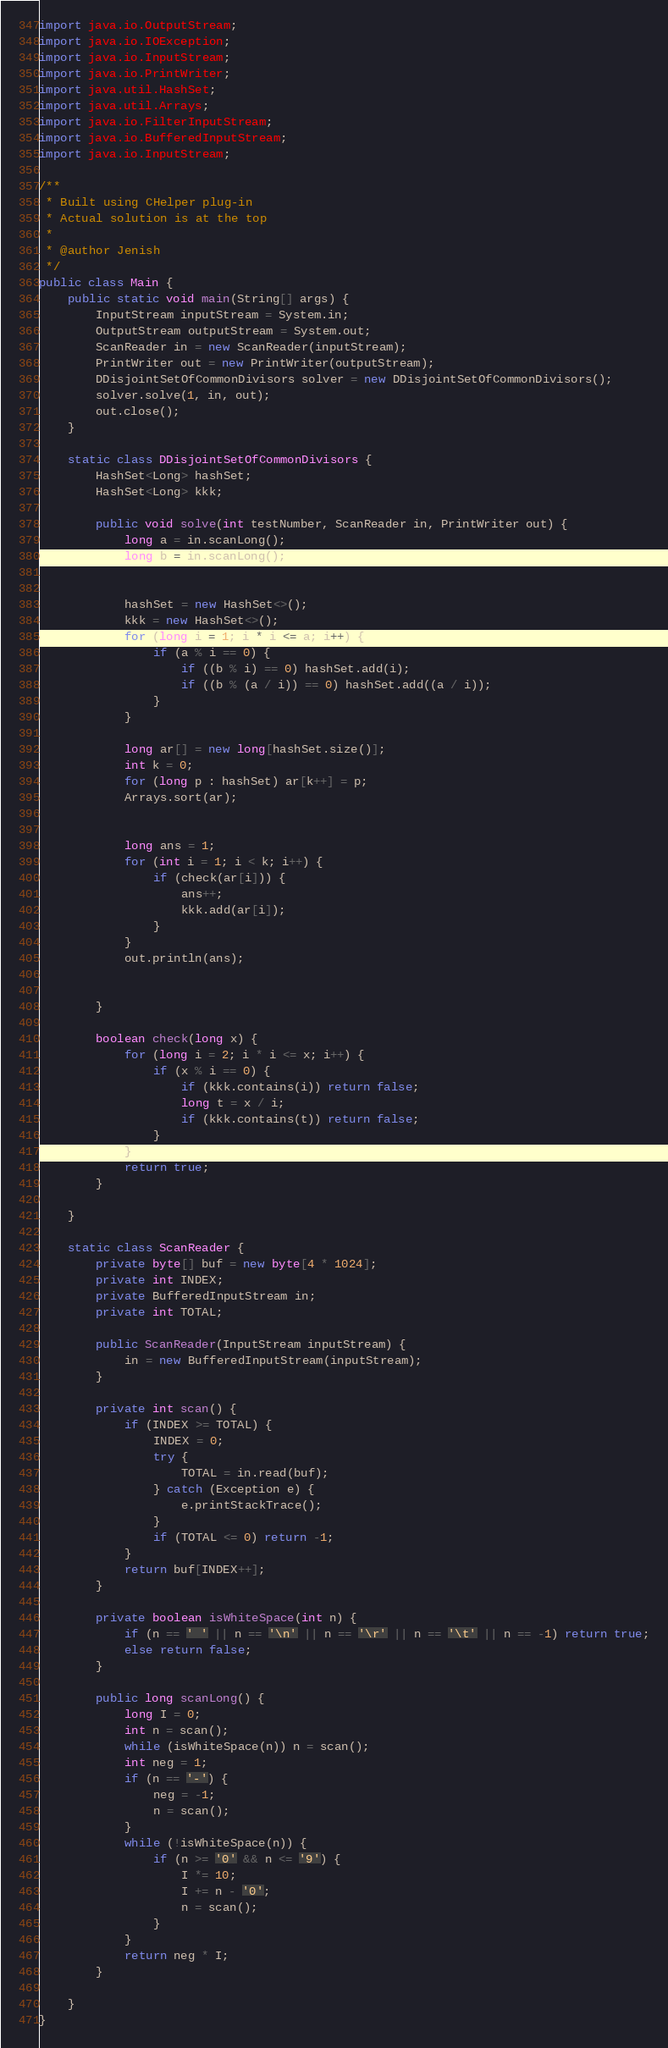<code> <loc_0><loc_0><loc_500><loc_500><_Java_>import java.io.OutputStream;
import java.io.IOException;
import java.io.InputStream;
import java.io.PrintWriter;
import java.util.HashSet;
import java.util.Arrays;
import java.io.FilterInputStream;
import java.io.BufferedInputStream;
import java.io.InputStream;

/**
 * Built using CHelper plug-in
 * Actual solution is at the top
 *
 * @author Jenish
 */
public class Main {
    public static void main(String[] args) {
        InputStream inputStream = System.in;
        OutputStream outputStream = System.out;
        ScanReader in = new ScanReader(inputStream);
        PrintWriter out = new PrintWriter(outputStream);
        DDisjointSetOfCommonDivisors solver = new DDisjointSetOfCommonDivisors();
        solver.solve(1, in, out);
        out.close();
    }

    static class DDisjointSetOfCommonDivisors {
        HashSet<Long> hashSet;
        HashSet<Long> kkk;

        public void solve(int testNumber, ScanReader in, PrintWriter out) {
            long a = in.scanLong();
            long b = in.scanLong();


            hashSet = new HashSet<>();
            kkk = new HashSet<>();
            for (long i = 1; i * i <= a; i++) {
                if (a % i == 0) {
                    if ((b % i) == 0) hashSet.add(i);
                    if ((b % (a / i)) == 0) hashSet.add((a / i));
                }
            }

            long ar[] = new long[hashSet.size()];
            int k = 0;
            for (long p : hashSet) ar[k++] = p;
            Arrays.sort(ar);


            long ans = 1;
            for (int i = 1; i < k; i++) {
                if (check(ar[i])) {
                    ans++;
                    kkk.add(ar[i]);
                }
            }
            out.println(ans);


        }

        boolean check(long x) {
            for (long i = 2; i * i <= x; i++) {
                if (x % i == 0) {
                    if (kkk.contains(i)) return false;
                    long t = x / i;
                    if (kkk.contains(t)) return false;
                }
            }
            return true;
        }

    }

    static class ScanReader {
        private byte[] buf = new byte[4 * 1024];
        private int INDEX;
        private BufferedInputStream in;
        private int TOTAL;

        public ScanReader(InputStream inputStream) {
            in = new BufferedInputStream(inputStream);
        }

        private int scan() {
            if (INDEX >= TOTAL) {
                INDEX = 0;
                try {
                    TOTAL = in.read(buf);
                } catch (Exception e) {
                    e.printStackTrace();
                }
                if (TOTAL <= 0) return -1;
            }
            return buf[INDEX++];
        }

        private boolean isWhiteSpace(int n) {
            if (n == ' ' || n == '\n' || n == '\r' || n == '\t' || n == -1) return true;
            else return false;
        }

        public long scanLong() {
            long I = 0;
            int n = scan();
            while (isWhiteSpace(n)) n = scan();
            int neg = 1;
            if (n == '-') {
                neg = -1;
                n = scan();
            }
            while (!isWhiteSpace(n)) {
                if (n >= '0' && n <= '9') {
                    I *= 10;
                    I += n - '0';
                    n = scan();
                }
            }
            return neg * I;
        }

    }
}

</code> 